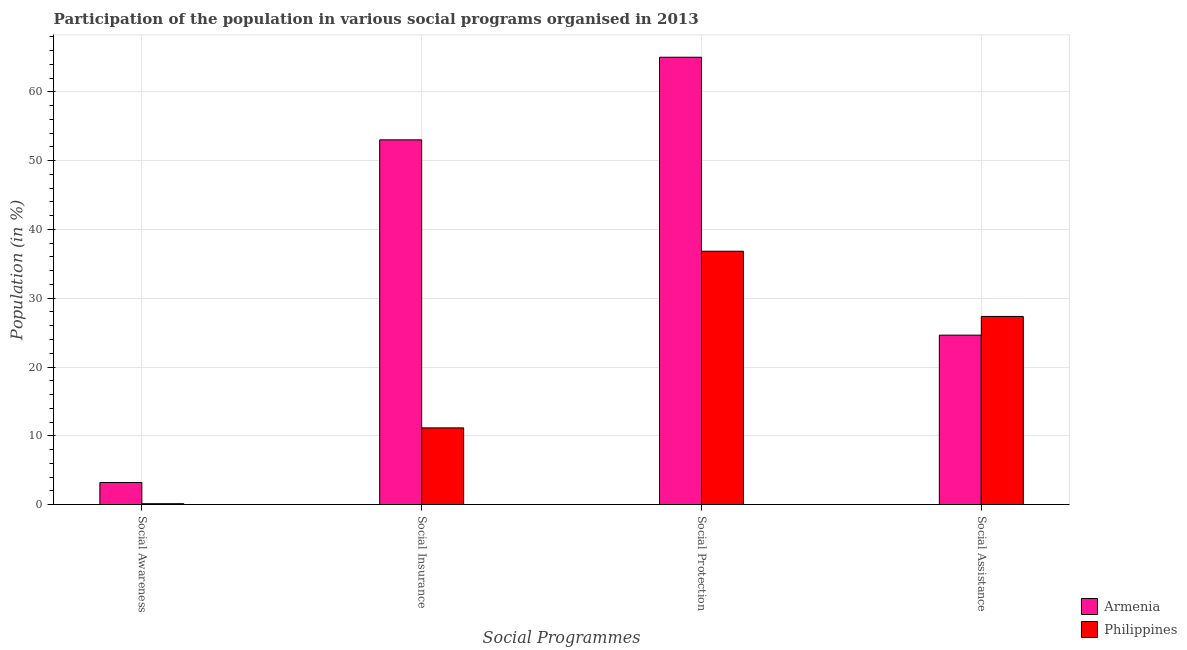Are the number of bars on each tick of the X-axis equal?
Provide a short and direct response. Yes. How many bars are there on the 3rd tick from the left?
Give a very brief answer. 2. What is the label of the 2nd group of bars from the left?
Give a very brief answer. Social Insurance. What is the participation of population in social awareness programs in Armenia?
Provide a short and direct response. 3.21. Across all countries, what is the maximum participation of population in social awareness programs?
Your answer should be compact. 3.21. Across all countries, what is the minimum participation of population in social awareness programs?
Ensure brevity in your answer.  0.12. In which country was the participation of population in social awareness programs maximum?
Give a very brief answer. Armenia. In which country was the participation of population in social assistance programs minimum?
Ensure brevity in your answer.  Armenia. What is the total participation of population in social protection programs in the graph?
Keep it short and to the point. 101.88. What is the difference between the participation of population in social awareness programs in Armenia and that in Philippines?
Provide a succinct answer. 3.08. What is the difference between the participation of population in social insurance programs in Philippines and the participation of population in social protection programs in Armenia?
Provide a short and direct response. -53.9. What is the average participation of population in social awareness programs per country?
Offer a terse response. 1.66. What is the difference between the participation of population in social insurance programs and participation of population in social protection programs in Philippines?
Your answer should be very brief. -25.69. What is the ratio of the participation of population in social protection programs in Philippines to that in Armenia?
Offer a terse response. 0.57. Is the difference between the participation of population in social protection programs in Philippines and Armenia greater than the difference between the participation of population in social assistance programs in Philippines and Armenia?
Offer a terse response. No. What is the difference between the highest and the second highest participation of population in social protection programs?
Your response must be concise. 28.21. What is the difference between the highest and the lowest participation of population in social awareness programs?
Provide a succinct answer. 3.08. In how many countries, is the participation of population in social awareness programs greater than the average participation of population in social awareness programs taken over all countries?
Provide a short and direct response. 1. What does the 1st bar from the left in Social Insurance represents?
Give a very brief answer. Armenia. What is the difference between two consecutive major ticks on the Y-axis?
Your response must be concise. 10. Are the values on the major ticks of Y-axis written in scientific E-notation?
Offer a terse response. No. Does the graph contain grids?
Ensure brevity in your answer.  Yes. Where does the legend appear in the graph?
Offer a very short reply. Bottom right. How are the legend labels stacked?
Make the answer very short. Vertical. What is the title of the graph?
Offer a terse response. Participation of the population in various social programs organised in 2013. What is the label or title of the X-axis?
Your answer should be very brief. Social Programmes. What is the label or title of the Y-axis?
Your answer should be very brief. Population (in %). What is the Population (in %) in Armenia in Social Awareness?
Provide a succinct answer. 3.21. What is the Population (in %) in Philippines in Social Awareness?
Your answer should be very brief. 0.12. What is the Population (in %) in Armenia in Social Insurance?
Provide a succinct answer. 53.03. What is the Population (in %) in Philippines in Social Insurance?
Keep it short and to the point. 11.15. What is the Population (in %) in Armenia in Social Protection?
Make the answer very short. 65.04. What is the Population (in %) in Philippines in Social Protection?
Ensure brevity in your answer.  36.84. What is the Population (in %) in Armenia in Social Assistance?
Your answer should be compact. 24.63. What is the Population (in %) of Philippines in Social Assistance?
Offer a terse response. 27.35. Across all Social Programmes, what is the maximum Population (in %) of Armenia?
Give a very brief answer. 65.04. Across all Social Programmes, what is the maximum Population (in %) in Philippines?
Ensure brevity in your answer.  36.84. Across all Social Programmes, what is the minimum Population (in %) in Armenia?
Offer a very short reply. 3.21. Across all Social Programmes, what is the minimum Population (in %) of Philippines?
Provide a short and direct response. 0.12. What is the total Population (in %) of Armenia in the graph?
Make the answer very short. 145.91. What is the total Population (in %) of Philippines in the graph?
Your answer should be very brief. 75.46. What is the difference between the Population (in %) in Armenia in Social Awareness and that in Social Insurance?
Provide a short and direct response. -49.83. What is the difference between the Population (in %) of Philippines in Social Awareness and that in Social Insurance?
Offer a very short reply. -11.02. What is the difference between the Population (in %) of Armenia in Social Awareness and that in Social Protection?
Provide a short and direct response. -61.84. What is the difference between the Population (in %) in Philippines in Social Awareness and that in Social Protection?
Provide a short and direct response. -36.71. What is the difference between the Population (in %) in Armenia in Social Awareness and that in Social Assistance?
Keep it short and to the point. -21.43. What is the difference between the Population (in %) in Philippines in Social Awareness and that in Social Assistance?
Your answer should be very brief. -27.23. What is the difference between the Population (in %) in Armenia in Social Insurance and that in Social Protection?
Offer a terse response. -12.01. What is the difference between the Population (in %) of Philippines in Social Insurance and that in Social Protection?
Provide a short and direct response. -25.69. What is the difference between the Population (in %) in Armenia in Social Insurance and that in Social Assistance?
Make the answer very short. 28.4. What is the difference between the Population (in %) in Philippines in Social Insurance and that in Social Assistance?
Give a very brief answer. -16.21. What is the difference between the Population (in %) of Armenia in Social Protection and that in Social Assistance?
Provide a short and direct response. 40.41. What is the difference between the Population (in %) of Philippines in Social Protection and that in Social Assistance?
Offer a very short reply. 9.48. What is the difference between the Population (in %) of Armenia in Social Awareness and the Population (in %) of Philippines in Social Insurance?
Your response must be concise. -7.94. What is the difference between the Population (in %) in Armenia in Social Awareness and the Population (in %) in Philippines in Social Protection?
Offer a very short reply. -33.63. What is the difference between the Population (in %) of Armenia in Social Awareness and the Population (in %) of Philippines in Social Assistance?
Your answer should be compact. -24.15. What is the difference between the Population (in %) in Armenia in Social Insurance and the Population (in %) in Philippines in Social Protection?
Ensure brevity in your answer.  16.2. What is the difference between the Population (in %) of Armenia in Social Insurance and the Population (in %) of Philippines in Social Assistance?
Keep it short and to the point. 25.68. What is the difference between the Population (in %) of Armenia in Social Protection and the Population (in %) of Philippines in Social Assistance?
Your answer should be compact. 37.69. What is the average Population (in %) of Armenia per Social Programmes?
Provide a short and direct response. 36.48. What is the average Population (in %) of Philippines per Social Programmes?
Provide a short and direct response. 18.86. What is the difference between the Population (in %) in Armenia and Population (in %) in Philippines in Social Awareness?
Your answer should be compact. 3.08. What is the difference between the Population (in %) in Armenia and Population (in %) in Philippines in Social Insurance?
Offer a very short reply. 41.88. What is the difference between the Population (in %) of Armenia and Population (in %) of Philippines in Social Protection?
Your response must be concise. 28.21. What is the difference between the Population (in %) in Armenia and Population (in %) in Philippines in Social Assistance?
Your answer should be compact. -2.72. What is the ratio of the Population (in %) in Armenia in Social Awareness to that in Social Insurance?
Offer a terse response. 0.06. What is the ratio of the Population (in %) of Philippines in Social Awareness to that in Social Insurance?
Offer a very short reply. 0.01. What is the ratio of the Population (in %) in Armenia in Social Awareness to that in Social Protection?
Your answer should be compact. 0.05. What is the ratio of the Population (in %) of Philippines in Social Awareness to that in Social Protection?
Your answer should be compact. 0. What is the ratio of the Population (in %) of Armenia in Social Awareness to that in Social Assistance?
Your answer should be very brief. 0.13. What is the ratio of the Population (in %) in Philippines in Social Awareness to that in Social Assistance?
Provide a short and direct response. 0. What is the ratio of the Population (in %) of Armenia in Social Insurance to that in Social Protection?
Ensure brevity in your answer.  0.82. What is the ratio of the Population (in %) in Philippines in Social Insurance to that in Social Protection?
Provide a short and direct response. 0.3. What is the ratio of the Population (in %) of Armenia in Social Insurance to that in Social Assistance?
Offer a terse response. 2.15. What is the ratio of the Population (in %) of Philippines in Social Insurance to that in Social Assistance?
Keep it short and to the point. 0.41. What is the ratio of the Population (in %) of Armenia in Social Protection to that in Social Assistance?
Make the answer very short. 2.64. What is the ratio of the Population (in %) of Philippines in Social Protection to that in Social Assistance?
Ensure brevity in your answer.  1.35. What is the difference between the highest and the second highest Population (in %) in Armenia?
Give a very brief answer. 12.01. What is the difference between the highest and the second highest Population (in %) of Philippines?
Provide a short and direct response. 9.48. What is the difference between the highest and the lowest Population (in %) in Armenia?
Make the answer very short. 61.84. What is the difference between the highest and the lowest Population (in %) of Philippines?
Keep it short and to the point. 36.71. 